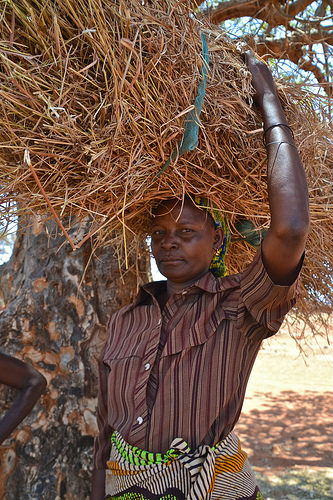<image>
Is there a woman in front of the dried grass? No. The woman is not in front of the dried grass. The spatial positioning shows a different relationship between these objects. Is the grass bundle above the womans arm? Yes. The grass bundle is positioned above the womans arm in the vertical space, higher up in the scene. 